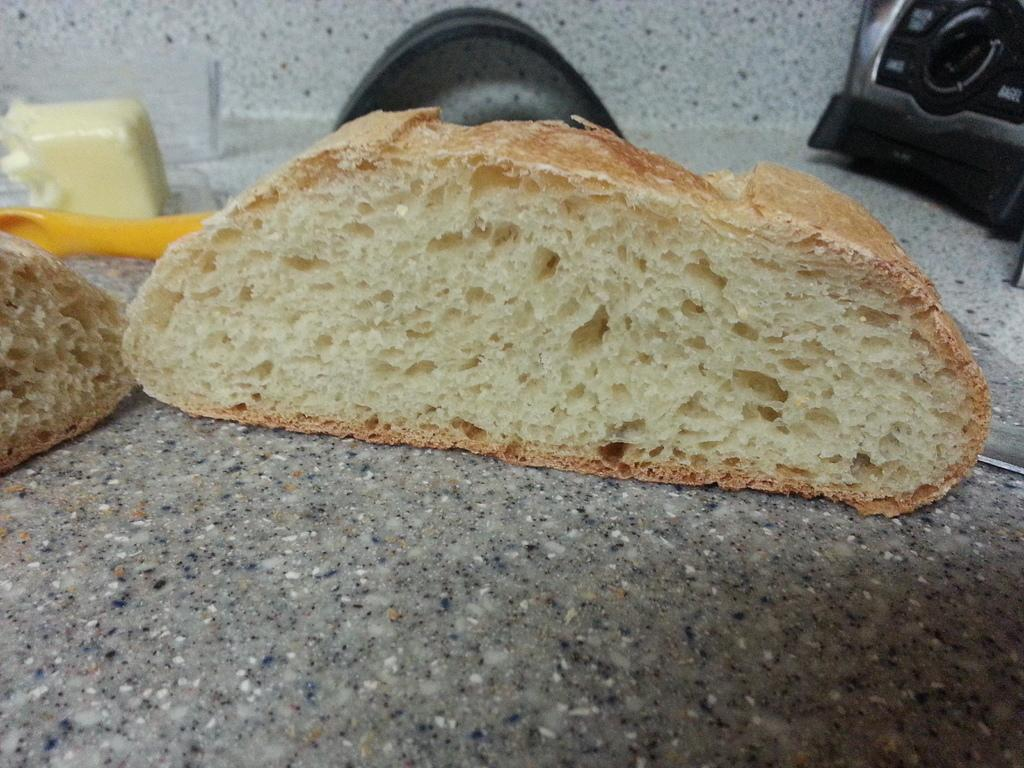What is present in the image that people typically consume? There is food in the image. What colors are featured on the objects on the countertop? The black and yellow color objects are on a countertop. Can you describe the location of these objects? The black and yellow color objects are on a countertop. What type of flowers can be seen growing on the countertop in the image? There are no flowers present in the image; the focus is on the food and black and yellow color objects on the countertop. What substance is being used with a quill in the image? There is no quill or substance present in the image. 